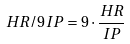<formula> <loc_0><loc_0><loc_500><loc_500>H R / 9 I P = 9 \cdot \frac { H R } { I P }</formula> 